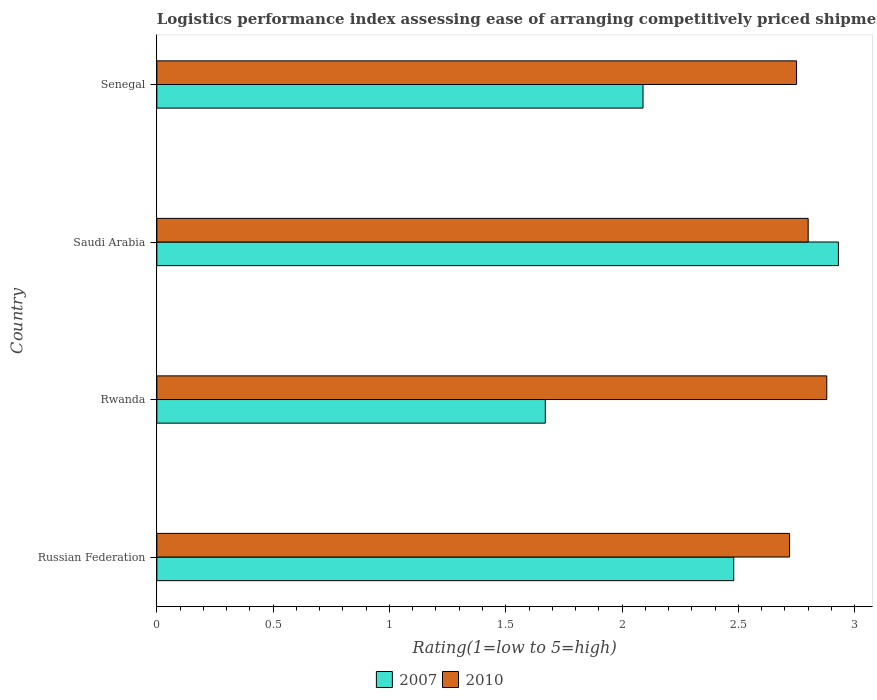How many different coloured bars are there?
Your response must be concise. 2. Are the number of bars per tick equal to the number of legend labels?
Offer a very short reply. Yes. Are the number of bars on each tick of the Y-axis equal?
Your response must be concise. Yes. How many bars are there on the 2nd tick from the top?
Provide a short and direct response. 2. What is the label of the 3rd group of bars from the top?
Provide a succinct answer. Rwanda. In how many cases, is the number of bars for a given country not equal to the number of legend labels?
Offer a very short reply. 0. What is the Logistic performance index in 2007 in Russian Federation?
Your answer should be compact. 2.48. Across all countries, what is the maximum Logistic performance index in 2007?
Keep it short and to the point. 2.93. Across all countries, what is the minimum Logistic performance index in 2010?
Ensure brevity in your answer.  2.72. In which country was the Logistic performance index in 2007 maximum?
Give a very brief answer. Saudi Arabia. In which country was the Logistic performance index in 2010 minimum?
Your answer should be very brief. Russian Federation. What is the total Logistic performance index in 2010 in the graph?
Give a very brief answer. 11.15. What is the difference between the Logistic performance index in 2010 in Rwanda and that in Saudi Arabia?
Your response must be concise. 0.08. What is the difference between the Logistic performance index in 2007 in Rwanda and the Logistic performance index in 2010 in Saudi Arabia?
Ensure brevity in your answer.  -1.13. What is the average Logistic performance index in 2007 per country?
Make the answer very short. 2.29. What is the difference between the Logistic performance index in 2010 and Logistic performance index in 2007 in Saudi Arabia?
Provide a short and direct response. -0.13. What is the ratio of the Logistic performance index in 2010 in Russian Federation to that in Senegal?
Your answer should be very brief. 0.99. Is the Logistic performance index in 2007 in Russian Federation less than that in Saudi Arabia?
Provide a short and direct response. Yes. Is the difference between the Logistic performance index in 2010 in Rwanda and Saudi Arabia greater than the difference between the Logistic performance index in 2007 in Rwanda and Saudi Arabia?
Offer a very short reply. Yes. What is the difference between the highest and the second highest Logistic performance index in 2007?
Your response must be concise. 0.45. What is the difference between the highest and the lowest Logistic performance index in 2010?
Make the answer very short. 0.16. In how many countries, is the Logistic performance index in 2007 greater than the average Logistic performance index in 2007 taken over all countries?
Provide a succinct answer. 2. Is the sum of the Logistic performance index in 2010 in Rwanda and Senegal greater than the maximum Logistic performance index in 2007 across all countries?
Your answer should be very brief. Yes. What does the 1st bar from the top in Russian Federation represents?
Keep it short and to the point. 2010. What does the 1st bar from the bottom in Saudi Arabia represents?
Make the answer very short. 2007. Are all the bars in the graph horizontal?
Your answer should be compact. Yes. How many countries are there in the graph?
Your response must be concise. 4. What is the difference between two consecutive major ticks on the X-axis?
Make the answer very short. 0.5. Are the values on the major ticks of X-axis written in scientific E-notation?
Offer a terse response. No. Does the graph contain any zero values?
Provide a short and direct response. No. What is the title of the graph?
Offer a very short reply. Logistics performance index assessing ease of arranging competitively priced shipments to markets. Does "1995" appear as one of the legend labels in the graph?
Offer a terse response. No. What is the label or title of the X-axis?
Provide a short and direct response. Rating(1=low to 5=high). What is the label or title of the Y-axis?
Give a very brief answer. Country. What is the Rating(1=low to 5=high) in 2007 in Russian Federation?
Offer a very short reply. 2.48. What is the Rating(1=low to 5=high) of 2010 in Russian Federation?
Offer a terse response. 2.72. What is the Rating(1=low to 5=high) of 2007 in Rwanda?
Keep it short and to the point. 1.67. What is the Rating(1=low to 5=high) of 2010 in Rwanda?
Your response must be concise. 2.88. What is the Rating(1=low to 5=high) of 2007 in Saudi Arabia?
Ensure brevity in your answer.  2.93. What is the Rating(1=low to 5=high) of 2010 in Saudi Arabia?
Give a very brief answer. 2.8. What is the Rating(1=low to 5=high) of 2007 in Senegal?
Offer a very short reply. 2.09. What is the Rating(1=low to 5=high) of 2010 in Senegal?
Make the answer very short. 2.75. Across all countries, what is the maximum Rating(1=low to 5=high) in 2007?
Offer a very short reply. 2.93. Across all countries, what is the maximum Rating(1=low to 5=high) of 2010?
Ensure brevity in your answer.  2.88. Across all countries, what is the minimum Rating(1=low to 5=high) in 2007?
Give a very brief answer. 1.67. Across all countries, what is the minimum Rating(1=low to 5=high) of 2010?
Your answer should be very brief. 2.72. What is the total Rating(1=low to 5=high) of 2007 in the graph?
Your answer should be compact. 9.17. What is the total Rating(1=low to 5=high) of 2010 in the graph?
Your answer should be compact. 11.15. What is the difference between the Rating(1=low to 5=high) of 2007 in Russian Federation and that in Rwanda?
Provide a short and direct response. 0.81. What is the difference between the Rating(1=low to 5=high) in 2010 in Russian Federation and that in Rwanda?
Your answer should be compact. -0.16. What is the difference between the Rating(1=low to 5=high) in 2007 in Russian Federation and that in Saudi Arabia?
Make the answer very short. -0.45. What is the difference between the Rating(1=low to 5=high) in 2010 in Russian Federation and that in Saudi Arabia?
Your answer should be very brief. -0.08. What is the difference between the Rating(1=low to 5=high) of 2007 in Russian Federation and that in Senegal?
Provide a short and direct response. 0.39. What is the difference between the Rating(1=low to 5=high) of 2010 in Russian Federation and that in Senegal?
Offer a very short reply. -0.03. What is the difference between the Rating(1=low to 5=high) of 2007 in Rwanda and that in Saudi Arabia?
Keep it short and to the point. -1.26. What is the difference between the Rating(1=low to 5=high) in 2010 in Rwanda and that in Saudi Arabia?
Your response must be concise. 0.08. What is the difference between the Rating(1=low to 5=high) of 2007 in Rwanda and that in Senegal?
Offer a terse response. -0.42. What is the difference between the Rating(1=low to 5=high) of 2010 in Rwanda and that in Senegal?
Provide a succinct answer. 0.13. What is the difference between the Rating(1=low to 5=high) in 2007 in Saudi Arabia and that in Senegal?
Give a very brief answer. 0.84. What is the difference between the Rating(1=low to 5=high) in 2007 in Russian Federation and the Rating(1=low to 5=high) in 2010 in Saudi Arabia?
Make the answer very short. -0.32. What is the difference between the Rating(1=low to 5=high) of 2007 in Russian Federation and the Rating(1=low to 5=high) of 2010 in Senegal?
Provide a short and direct response. -0.27. What is the difference between the Rating(1=low to 5=high) of 2007 in Rwanda and the Rating(1=low to 5=high) of 2010 in Saudi Arabia?
Your answer should be very brief. -1.13. What is the difference between the Rating(1=low to 5=high) in 2007 in Rwanda and the Rating(1=low to 5=high) in 2010 in Senegal?
Provide a succinct answer. -1.08. What is the difference between the Rating(1=low to 5=high) of 2007 in Saudi Arabia and the Rating(1=low to 5=high) of 2010 in Senegal?
Keep it short and to the point. 0.18. What is the average Rating(1=low to 5=high) of 2007 per country?
Your answer should be compact. 2.29. What is the average Rating(1=low to 5=high) in 2010 per country?
Keep it short and to the point. 2.79. What is the difference between the Rating(1=low to 5=high) in 2007 and Rating(1=low to 5=high) in 2010 in Russian Federation?
Provide a succinct answer. -0.24. What is the difference between the Rating(1=low to 5=high) in 2007 and Rating(1=low to 5=high) in 2010 in Rwanda?
Provide a short and direct response. -1.21. What is the difference between the Rating(1=low to 5=high) of 2007 and Rating(1=low to 5=high) of 2010 in Saudi Arabia?
Provide a succinct answer. 0.13. What is the difference between the Rating(1=low to 5=high) of 2007 and Rating(1=low to 5=high) of 2010 in Senegal?
Offer a terse response. -0.66. What is the ratio of the Rating(1=low to 5=high) in 2007 in Russian Federation to that in Rwanda?
Provide a short and direct response. 1.49. What is the ratio of the Rating(1=low to 5=high) in 2010 in Russian Federation to that in Rwanda?
Make the answer very short. 0.94. What is the ratio of the Rating(1=low to 5=high) in 2007 in Russian Federation to that in Saudi Arabia?
Your answer should be very brief. 0.85. What is the ratio of the Rating(1=low to 5=high) of 2010 in Russian Federation to that in Saudi Arabia?
Your response must be concise. 0.97. What is the ratio of the Rating(1=low to 5=high) of 2007 in Russian Federation to that in Senegal?
Ensure brevity in your answer.  1.19. What is the ratio of the Rating(1=low to 5=high) in 2010 in Russian Federation to that in Senegal?
Your answer should be compact. 0.99. What is the ratio of the Rating(1=low to 5=high) of 2007 in Rwanda to that in Saudi Arabia?
Your answer should be compact. 0.57. What is the ratio of the Rating(1=low to 5=high) in 2010 in Rwanda to that in Saudi Arabia?
Your answer should be compact. 1.03. What is the ratio of the Rating(1=low to 5=high) of 2007 in Rwanda to that in Senegal?
Make the answer very short. 0.8. What is the ratio of the Rating(1=low to 5=high) of 2010 in Rwanda to that in Senegal?
Ensure brevity in your answer.  1.05. What is the ratio of the Rating(1=low to 5=high) in 2007 in Saudi Arabia to that in Senegal?
Make the answer very short. 1.4. What is the ratio of the Rating(1=low to 5=high) of 2010 in Saudi Arabia to that in Senegal?
Your answer should be very brief. 1.02. What is the difference between the highest and the second highest Rating(1=low to 5=high) in 2007?
Your answer should be very brief. 0.45. What is the difference between the highest and the second highest Rating(1=low to 5=high) in 2010?
Your answer should be very brief. 0.08. What is the difference between the highest and the lowest Rating(1=low to 5=high) in 2007?
Offer a terse response. 1.26. What is the difference between the highest and the lowest Rating(1=low to 5=high) of 2010?
Ensure brevity in your answer.  0.16. 